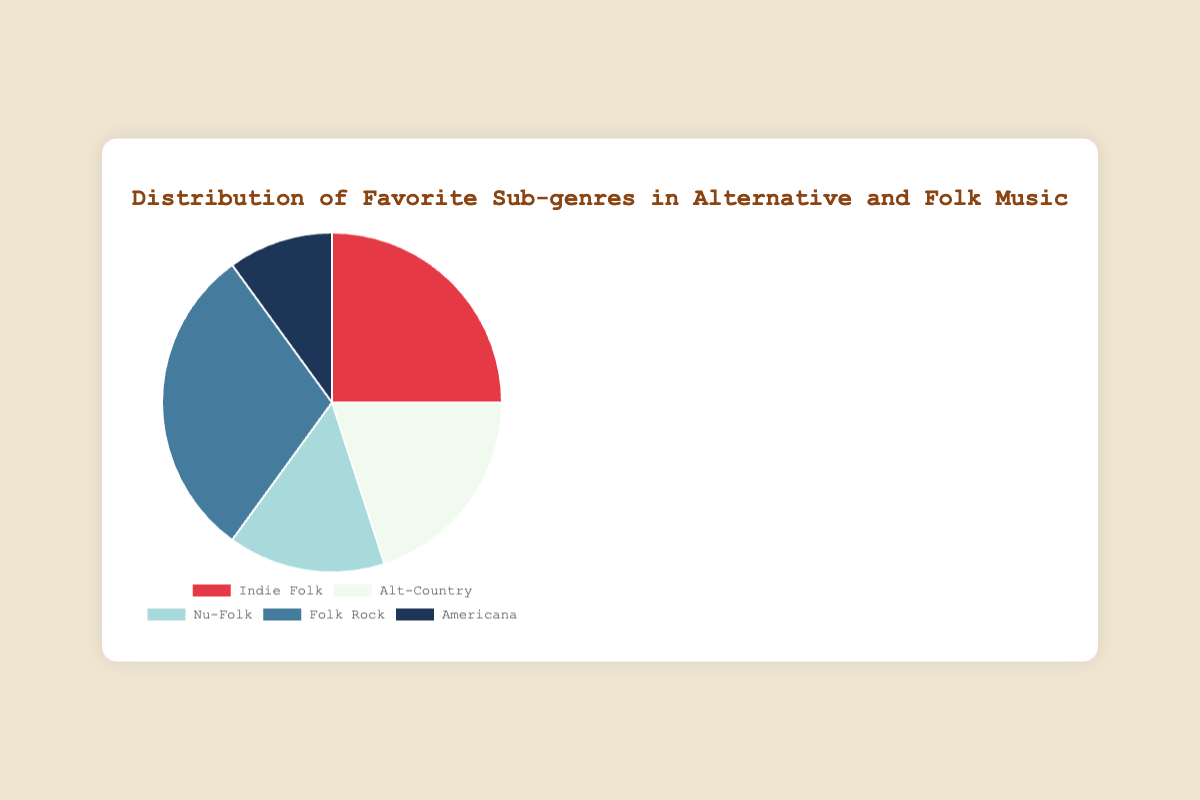What is the most popular sub-genre in alternative and folk music? The slice with the largest percentage representing Folk Rock indicates it has the highest percentage at 30%.
Answer: Folk Rock What percentage of people prefer Indie Folk compared to Nu-Folk? Indie Folk has a 25% preference, while Nu-Folk has a 15% preference. To compare, subtract Nu-Folk's percentage from Indie Folk's: 25% - 15% = 10%.
Answer: 10% Which sub-genre has a smaller audience, Americana or Alt-Country? Americana is represented by 10% of the pie chart, and Alt-Country by 20%. Since 10% is smaller than 20%, Americana has a smaller audience.
Answer: Americana What's the combined percentage of people who favor Nu-Folk and Americana? Nu-Folk has 15% and Americana has 10%. Adding them together: 15% + 10% = 25%.
Answer: 25% How does the popularity of Folk Rock compare to that of Alt-Country and Americana combined? Folk Rock is at 30%, while Alt-Country and Americana combined is 20% + 10% = 30%. Both percentages are equal.
Answer: Equal Which sub-genre is represented by the red slice? The red slice denotes Indie Folk, as indicated by the pie chart and corresponding legend.
Answer: Indie Folk Is the sum of the percentages of Indie Folk and Alt-Country greater than the percentage of Folk Rock? Indie Folk has 25% and Alt-Country has 20%. Combined they have: 25% + 20% = 45%, which is greater than Folk Rock's 30%.
Answer: Yes What percentage of people prefer neither Indie Folk nor Folk Rock? Indie Folk has 25% and Folk Rock has 30%. Subtracting these from 100%: 100% - (25% + 30%) = 45%.
Answer: 45% If you combine the least and most preferred sub-genres, what percentage do they make up? The least preferred sub-genre is Americana (10%) and the most preferred is Folk Rock (30%). Combined, they make up 10% + 30% = 40%.
Answer: 40% What is the average percentage across all sub-genres? Sum the percentages: 25% + 20% + 15% + 30% + 10% = 100%. The average is 100% / 5 = 20%.
Answer: 20% 